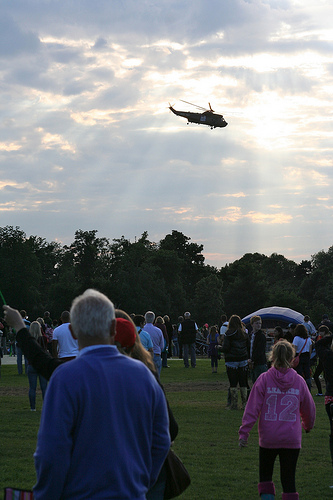<image>
Is there a girl to the left of the man? No. The girl is not to the left of the man. From this viewpoint, they have a different horizontal relationship. 